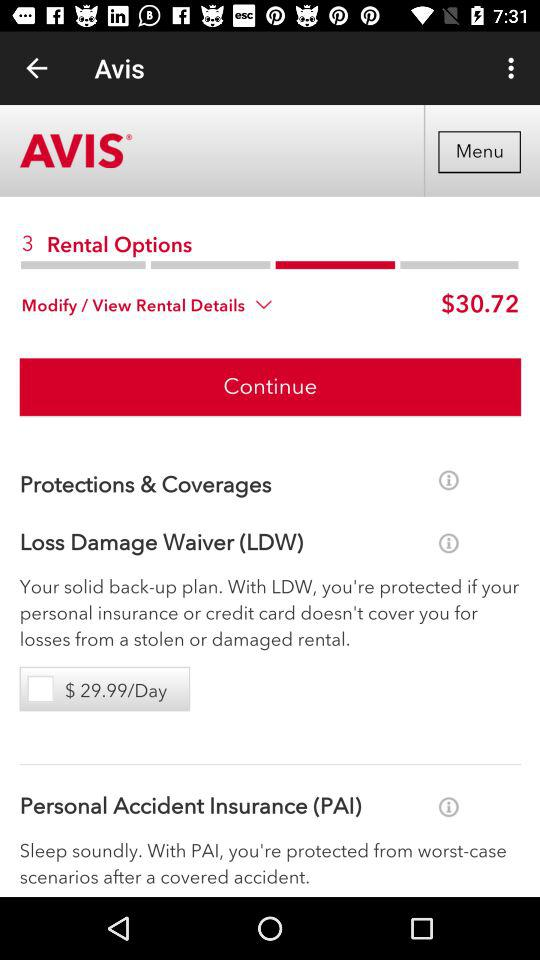What are the LDW per day charges? The LDW per day charges are $29.99. 